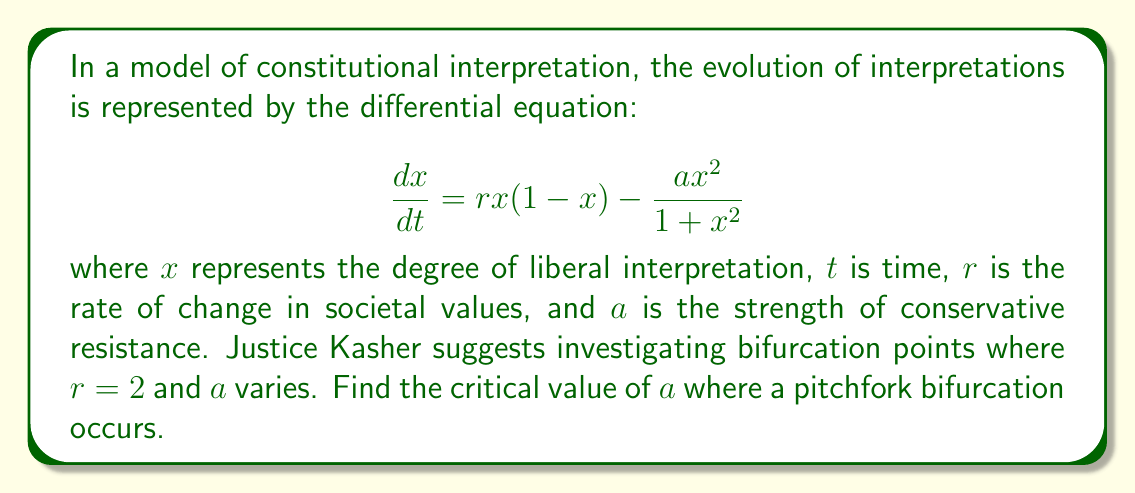Give your solution to this math problem. To find the pitchfork bifurcation point, we follow these steps:

1) First, find the equilibrium points by setting $\frac{dx}{dt} = 0$:

   $$rx(1-x) - \frac{ax^2}{1+x^2} = 0$$

2) Factor out $x$:

   $$x\left(r(1-x) - \frac{ax}{1+x^2}\right) = 0$$

3) One equilibrium is always $x = 0$. For the others, solve:

   $$r(1-x) - \frac{ax}{1+x^2} = 0$$

4) For a pitchfork bifurcation, we need three equilibria to coincide. This occurs when $x = 0$ is a triple root. For this to happen, the first and second derivatives of the right-hand side of the differential equation must be zero at $x = 0$.

5) The first derivative at $x = 0$ is:

   $$\left.\frac{d}{dx}\left(rx(1-x) - \frac{ax^2}{1+x^2}\right)\right|_{x=0} = r$$

6) The second derivative at $x = 0$ is:

   $$\left.\frac{d^2}{dx^2}\left(rx(1-x) - \frac{ax^2}{1+x^2}\right)\right|_{x=0} = -2r + 2a$$

7) For a pitchfork bifurcation, both must be zero. The first is already zero since $r = 2$. For the second:

   $$-2r + 2a = 0$$
   $$-2(2) + 2a = 0$$
   $$2a = 4$$
   $$a = 2$$

Therefore, the critical value of $a$ where a pitchfork bifurcation occurs is 2.
Answer: $a = 2$ 